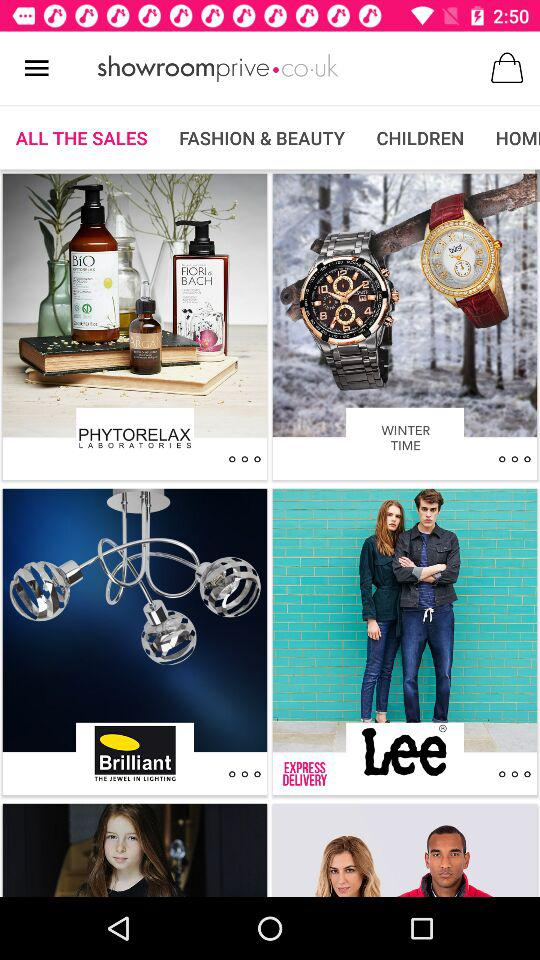Are there any items in the bag?
When the provided information is insufficient, respond with <no answer>. <no answer> 